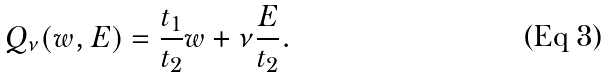<formula> <loc_0><loc_0><loc_500><loc_500>Q _ { \nu } ( w , E ) = \frac { t _ { 1 } } { t _ { 2 } } w + \nu \frac { E } { t _ { 2 } } .</formula> 